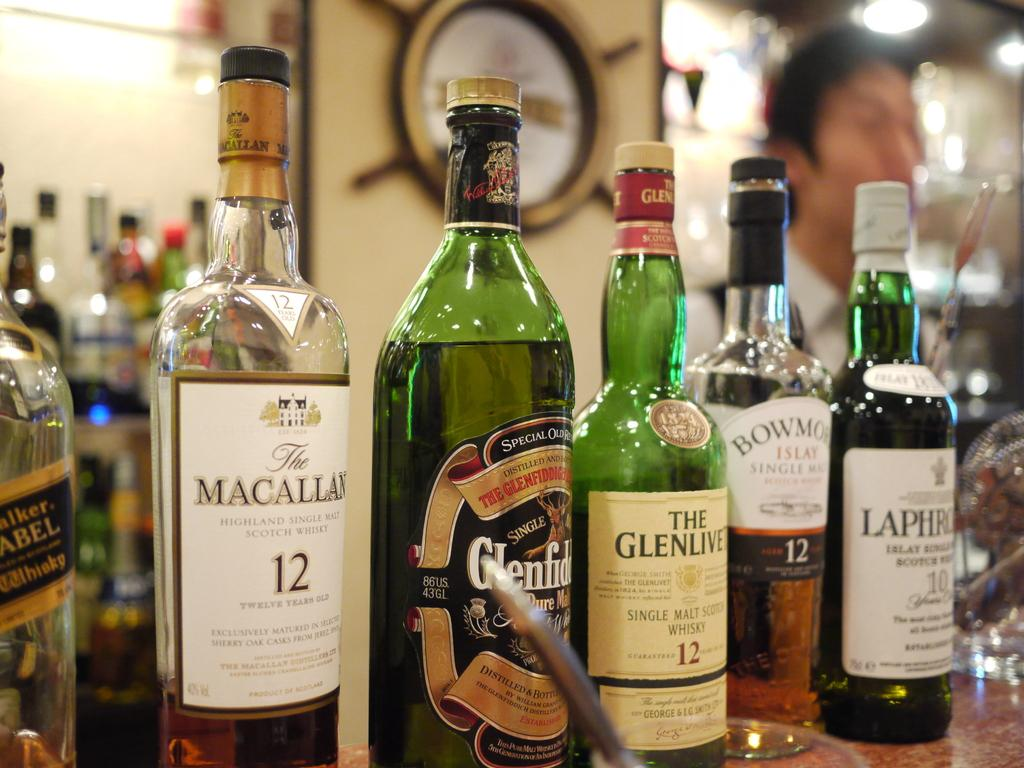<image>
Render a clear and concise summary of the photo. A green bottle thats say glenlivit on the label 